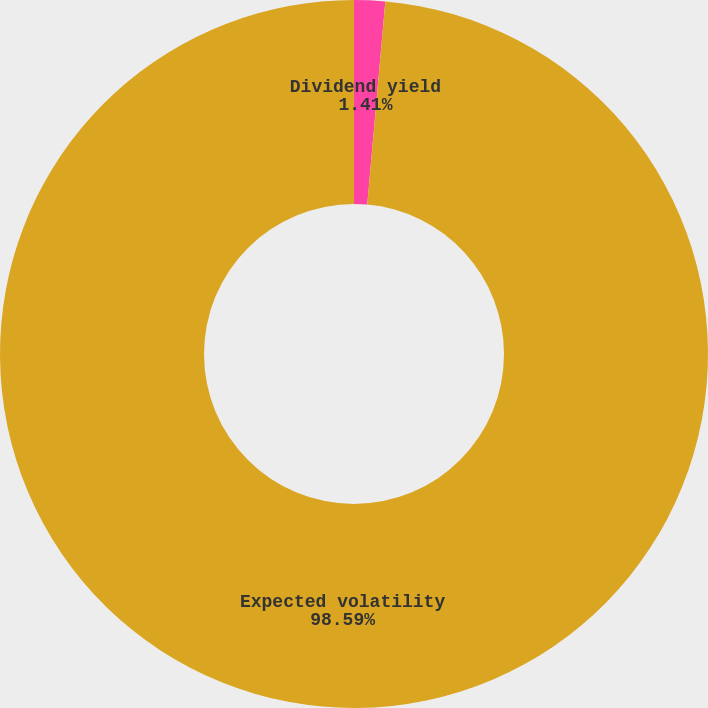<chart> <loc_0><loc_0><loc_500><loc_500><pie_chart><fcel>Dividend yield<fcel>Expected volatility<nl><fcel>1.41%<fcel>98.59%<nl></chart> 